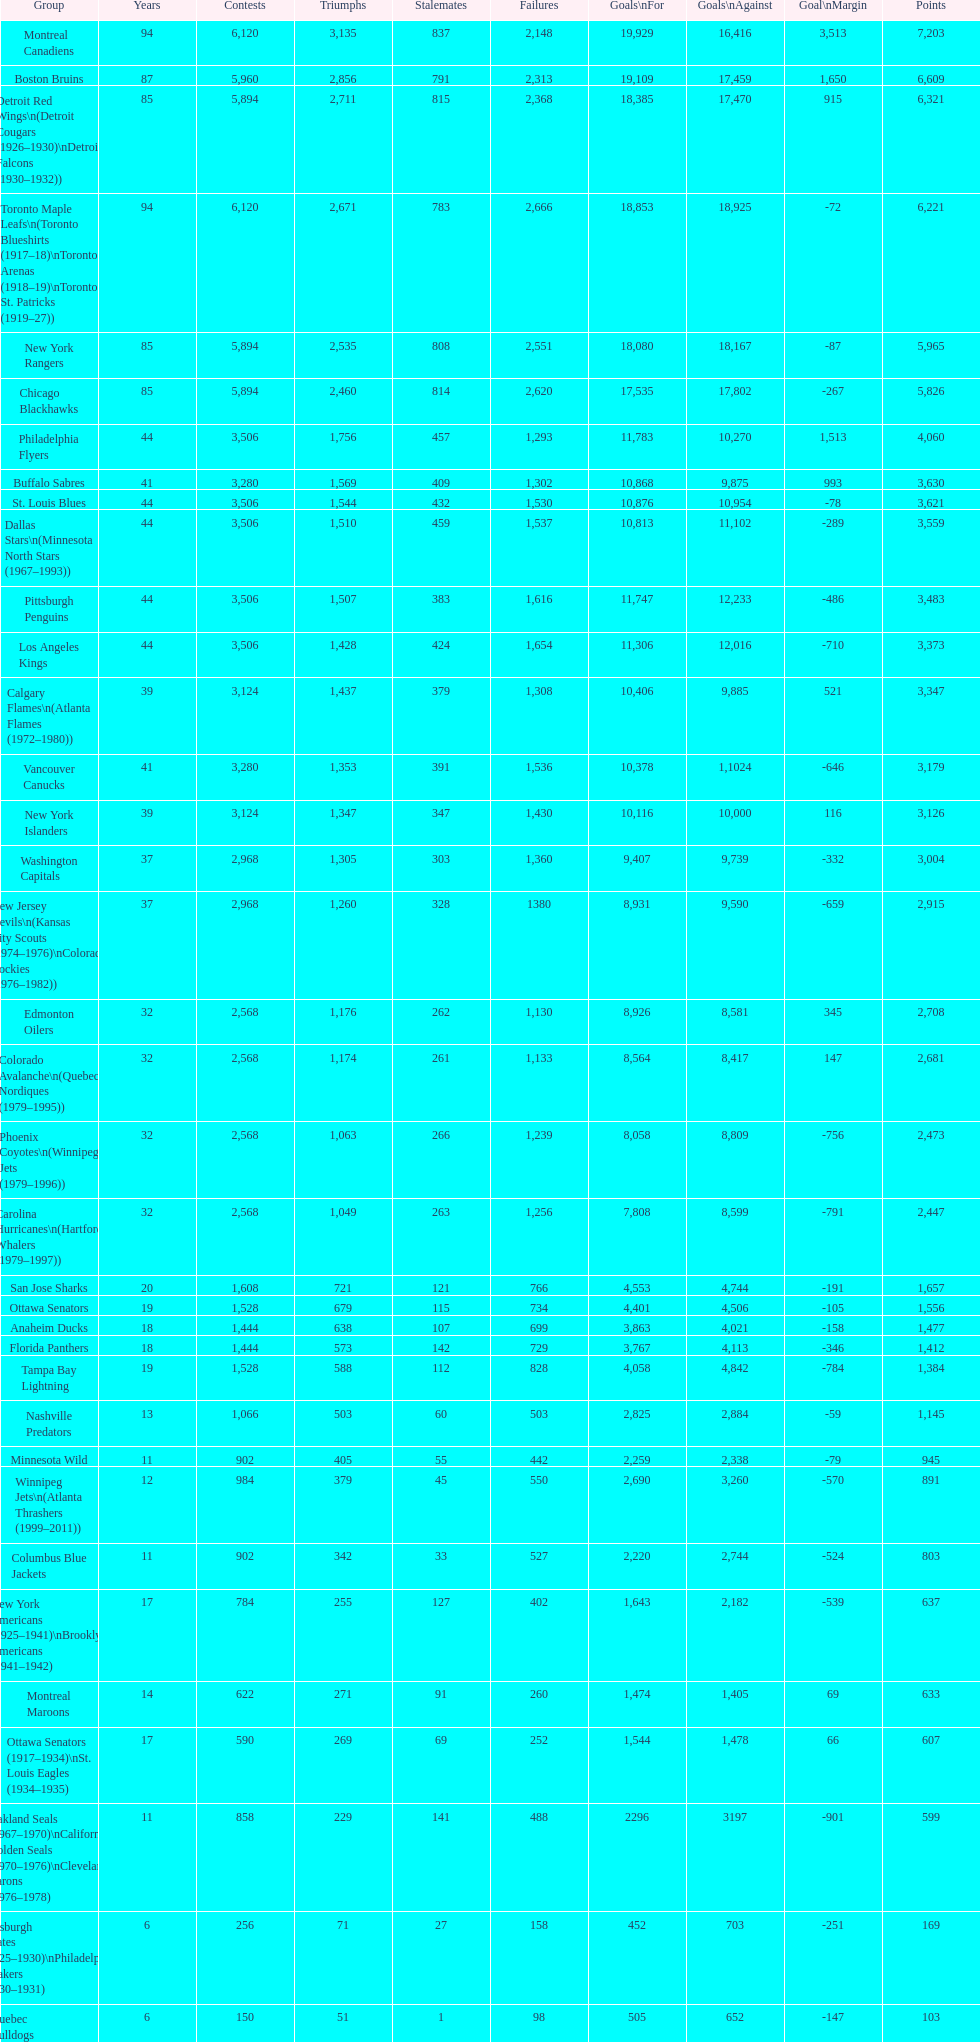How many total points has the lost angeles kings scored? 3,373. 